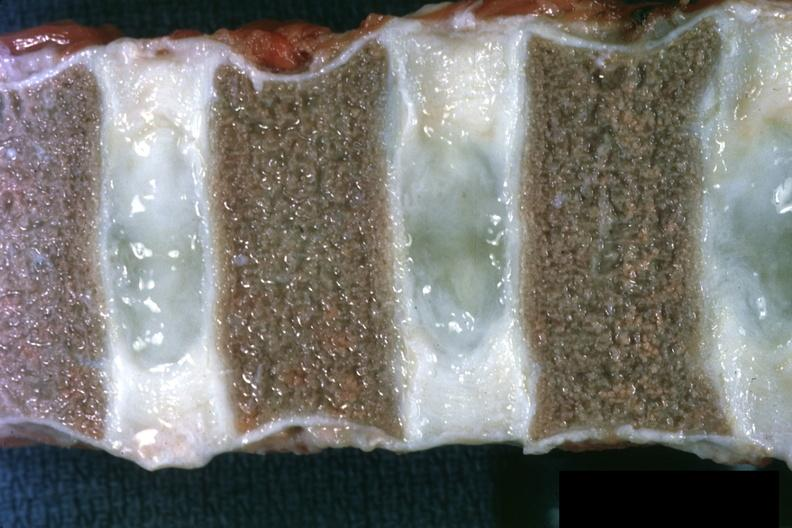what is close-up view of vertebral marrow not too spectacular discs are well shown and normal entered?
Answer the question using a single word or phrase. Normal entered into this file as slide 